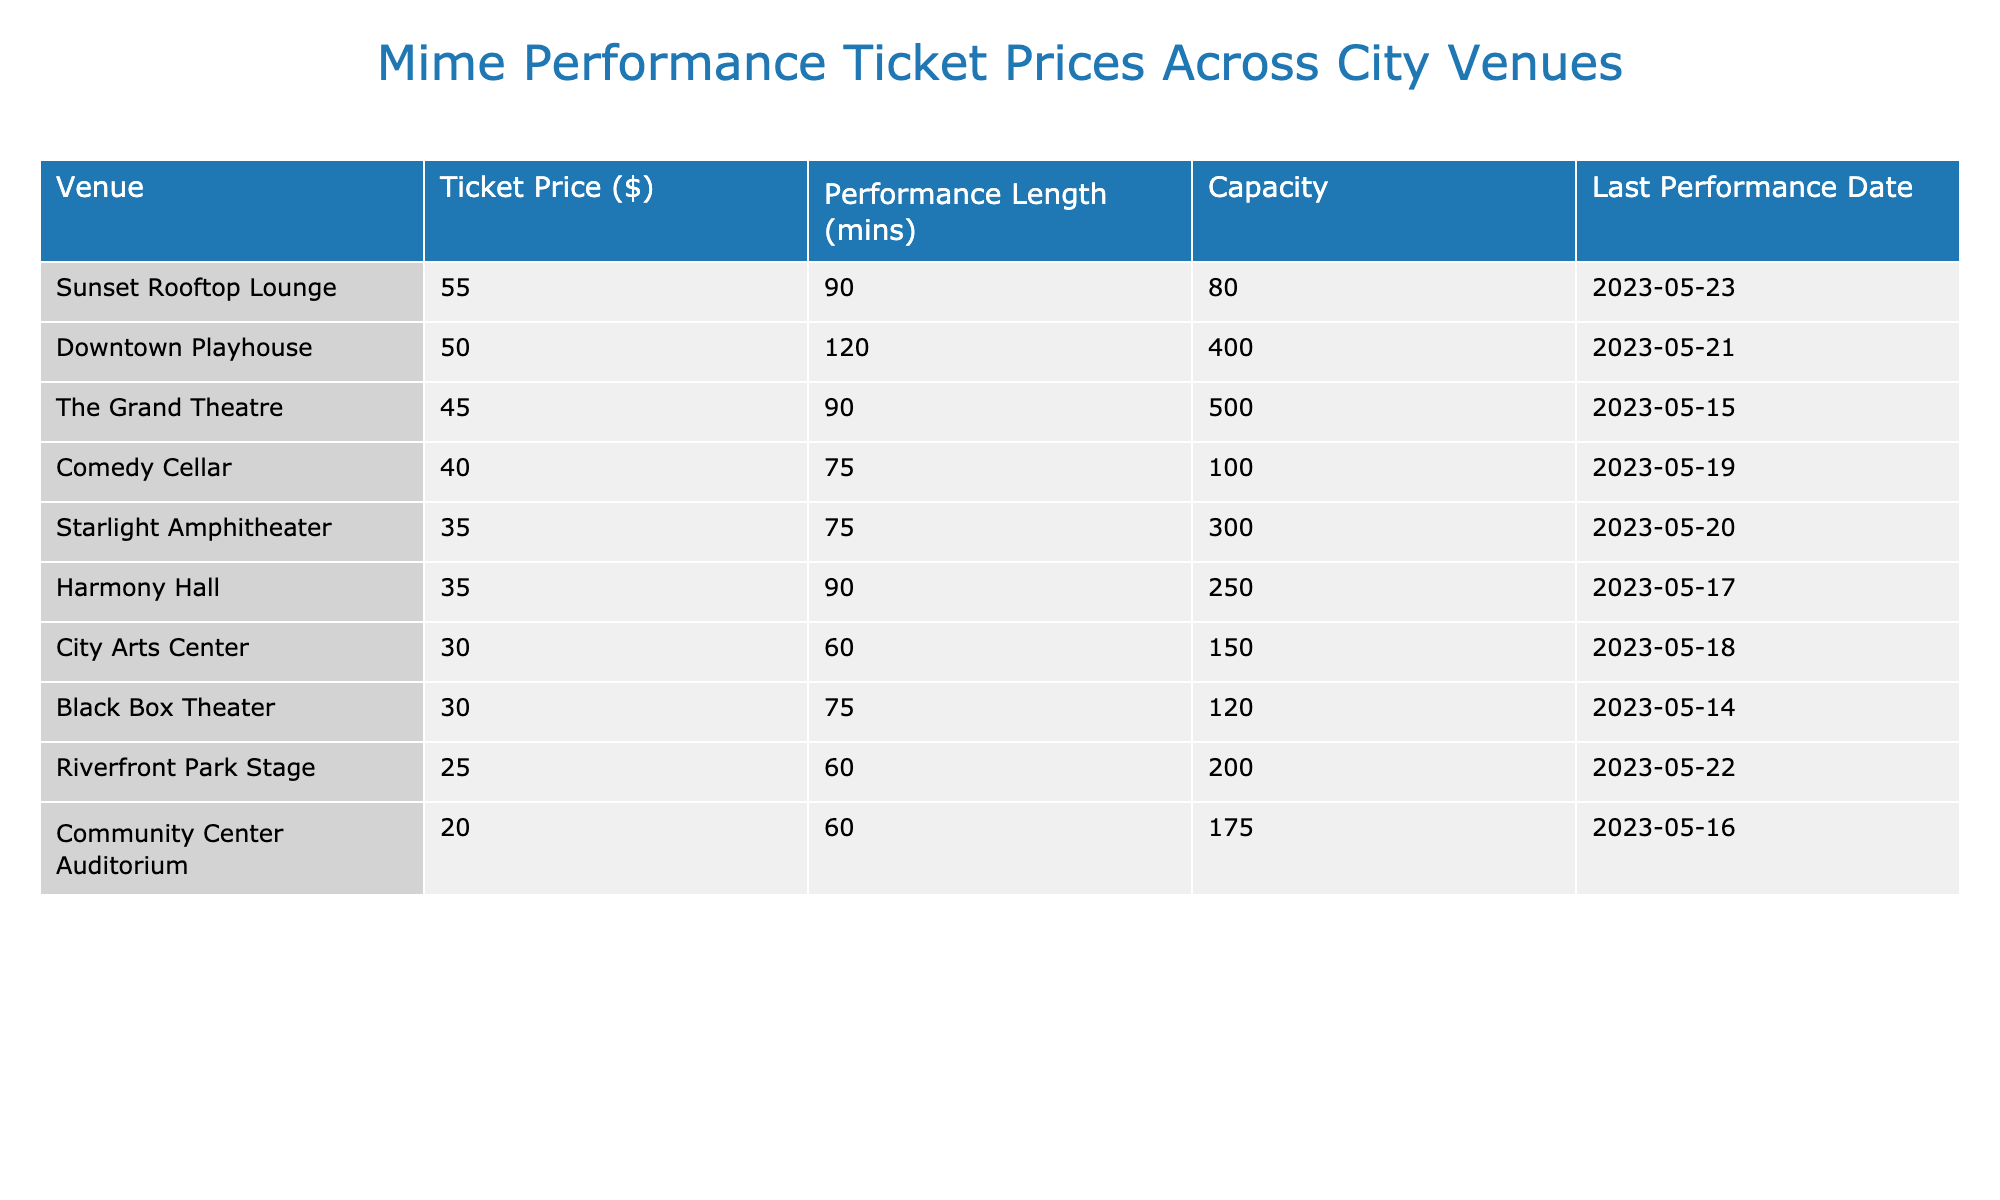What is the ticket price for the Downtown Playhouse? The table lists the ticket prices for each venue. Looking at the row for Downtown Playhouse, the ticket price is $50.
Answer: $50 Which venue has the lowest ticket price? By examining the ticket prices in the table, Riverfront Park Stage has the lowest price listed at $25.
Answer: $25 How long is the performance at the Starlight Amphitheater? The performance length for Starlight Amphitheater is directly given in the table, which shows 75 minutes.
Answer: 75 minutes What is the total capacity of all the venues combined? To find the total capacity, I sum the capacities of all venues listed: 500 + 300 + 150 + 200 + 100 + 250 + 400 + 175 + 80 + 120 = 1975.
Answer: 1975 Is the last performance date for Harmony Hall after Starlight Amphitheater's last performance date? The last performance date for Harmony Hall is 2023-05-17, and for Starlight Amphitheater, it is 2023-05-20. Since 2023-05-17 is before 2023-05-20, the statement is false.
Answer: No What is the average ticket price for the venues listed? To calculate the average ticket price, I add all ticket prices together: 45 + 35 + 30 + 25 + 40 + 35 + 50 + 20 + 55 + 30 =  415, and then divide by the number of venues (10) to get 415/10 = 41.5.
Answer: $41.5 Which venue has the longest performance duration, and what is it? I can observe the performance lengths in the table and see that Downtown Playhouse has the longest duration at 120 minutes.
Answer: Downtown Playhouse, 120 minutes How many venues have a ticket price higher than $40? By scanning the ticket prices in the table, I find the venues with prices above $40: The Grand Theatre ($45), Comedy Cellar ($40), and Downtown Playhouse ($50). There are 3 venues meeting this criterion.
Answer: 3 What is the difference in ticket price between the most expensive and the least expensive venue? The ticket price of the most expensive venue (Sunset Rooftop Lounge at $55) minus the ticket price of the least expensive venue (Riverfront Park Stage at $25) equals 55 - 25 = 30.
Answer: $30 Do any venues have a ticket price of $30? Looking through the table, both City Arts Center and Black Box Theater both have ticket prices listed at $30, which makes the statement true.
Answer: Yes 